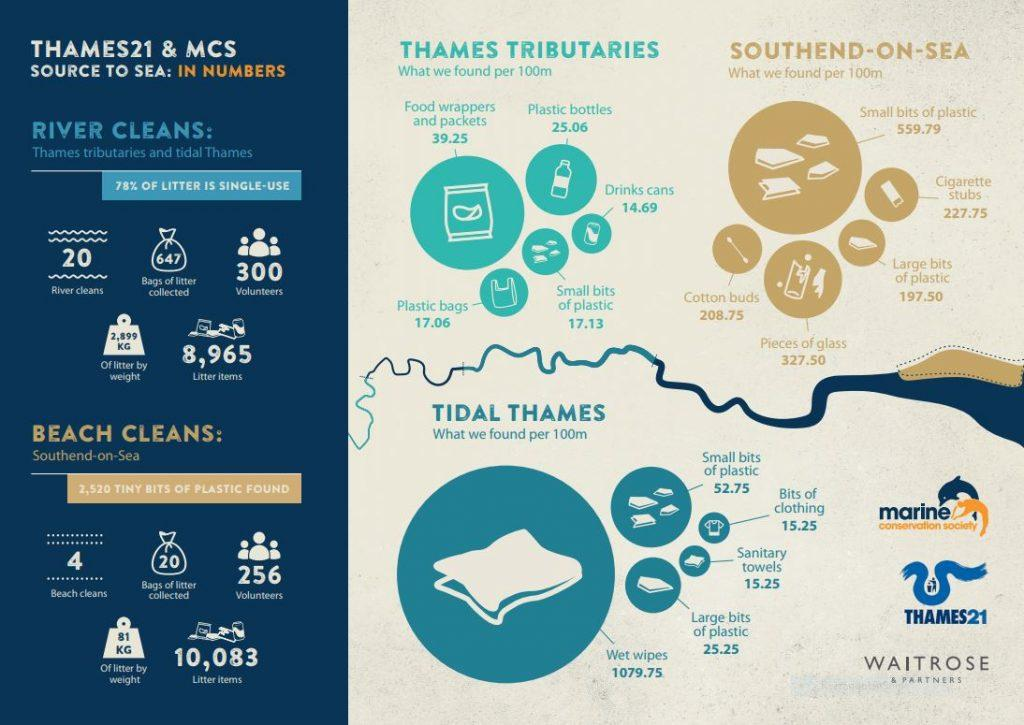Outline some significant characteristics in this image. A total of 24 rivers and beaches have been cleaned. The total number of litter items collected from rivers and beaches was 19,048. There were a total of 647 bags of litter collected. A total of 667 bags of litter were collected from rivers and beaches. 